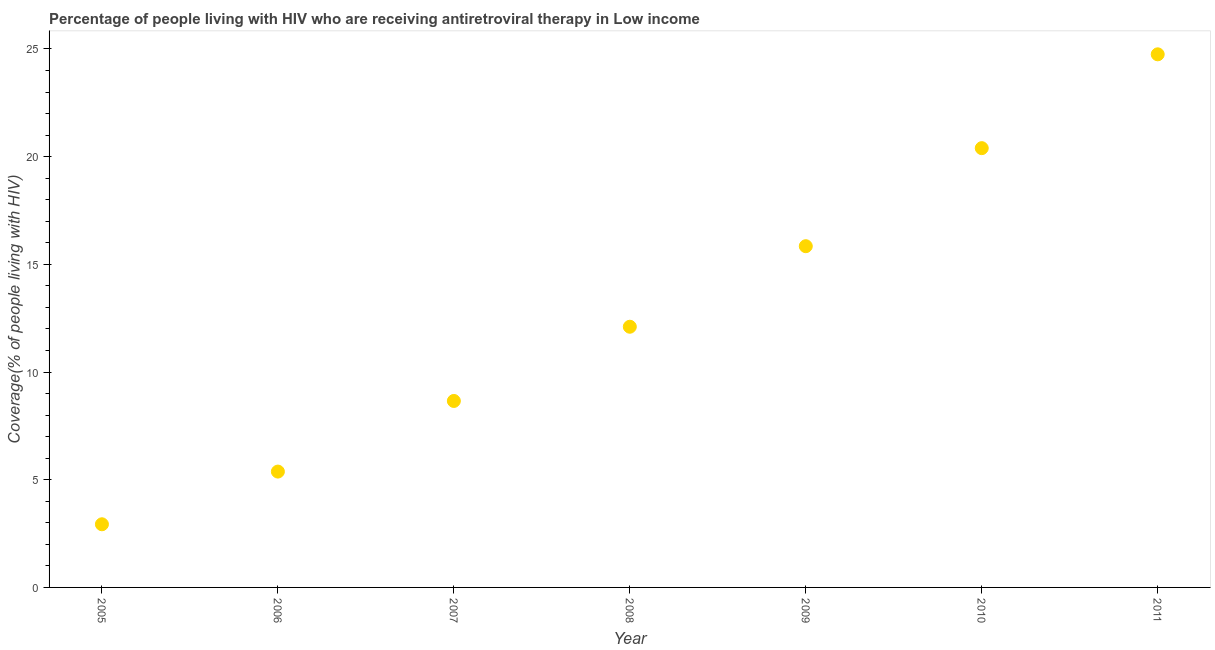What is the antiretroviral therapy coverage in 2008?
Keep it short and to the point. 12.1. Across all years, what is the maximum antiretroviral therapy coverage?
Ensure brevity in your answer.  24.75. Across all years, what is the minimum antiretroviral therapy coverage?
Your answer should be compact. 2.93. What is the sum of the antiretroviral therapy coverage?
Your answer should be very brief. 90.06. What is the difference between the antiretroviral therapy coverage in 2005 and 2009?
Provide a succinct answer. -12.91. What is the average antiretroviral therapy coverage per year?
Your answer should be very brief. 12.87. What is the median antiretroviral therapy coverage?
Ensure brevity in your answer.  12.1. In how many years, is the antiretroviral therapy coverage greater than 11 %?
Offer a terse response. 4. What is the ratio of the antiretroviral therapy coverage in 2005 to that in 2009?
Provide a succinct answer. 0.19. Is the antiretroviral therapy coverage in 2009 less than that in 2011?
Provide a succinct answer. Yes. Is the difference between the antiretroviral therapy coverage in 2010 and 2011 greater than the difference between any two years?
Ensure brevity in your answer.  No. What is the difference between the highest and the second highest antiretroviral therapy coverage?
Keep it short and to the point. 4.36. What is the difference between the highest and the lowest antiretroviral therapy coverage?
Provide a succinct answer. 21.82. Does the antiretroviral therapy coverage monotonically increase over the years?
Provide a short and direct response. Yes. How many dotlines are there?
Give a very brief answer. 1. Are the values on the major ticks of Y-axis written in scientific E-notation?
Ensure brevity in your answer.  No. Does the graph contain grids?
Your response must be concise. No. What is the title of the graph?
Offer a very short reply. Percentage of people living with HIV who are receiving antiretroviral therapy in Low income. What is the label or title of the Y-axis?
Give a very brief answer. Coverage(% of people living with HIV). What is the Coverage(% of people living with HIV) in 2005?
Give a very brief answer. 2.93. What is the Coverage(% of people living with HIV) in 2006?
Your response must be concise. 5.38. What is the Coverage(% of people living with HIV) in 2007?
Your response must be concise. 8.66. What is the Coverage(% of people living with HIV) in 2008?
Provide a succinct answer. 12.1. What is the Coverage(% of people living with HIV) in 2009?
Your answer should be compact. 15.84. What is the Coverage(% of people living with HIV) in 2010?
Ensure brevity in your answer.  20.39. What is the Coverage(% of people living with HIV) in 2011?
Provide a short and direct response. 24.75. What is the difference between the Coverage(% of people living with HIV) in 2005 and 2006?
Offer a very short reply. -2.45. What is the difference between the Coverage(% of people living with HIV) in 2005 and 2007?
Ensure brevity in your answer.  -5.73. What is the difference between the Coverage(% of people living with HIV) in 2005 and 2008?
Ensure brevity in your answer.  -9.17. What is the difference between the Coverage(% of people living with HIV) in 2005 and 2009?
Your response must be concise. -12.91. What is the difference between the Coverage(% of people living with HIV) in 2005 and 2010?
Give a very brief answer. -17.46. What is the difference between the Coverage(% of people living with HIV) in 2005 and 2011?
Provide a succinct answer. -21.82. What is the difference between the Coverage(% of people living with HIV) in 2006 and 2007?
Ensure brevity in your answer.  -3.28. What is the difference between the Coverage(% of people living with HIV) in 2006 and 2008?
Offer a very short reply. -6.72. What is the difference between the Coverage(% of people living with HIV) in 2006 and 2009?
Make the answer very short. -10.46. What is the difference between the Coverage(% of people living with HIV) in 2006 and 2010?
Offer a very short reply. -15.02. What is the difference between the Coverage(% of people living with HIV) in 2006 and 2011?
Offer a terse response. -19.37. What is the difference between the Coverage(% of people living with HIV) in 2007 and 2008?
Offer a very short reply. -3.45. What is the difference between the Coverage(% of people living with HIV) in 2007 and 2009?
Give a very brief answer. -7.18. What is the difference between the Coverage(% of people living with HIV) in 2007 and 2010?
Your answer should be compact. -11.74. What is the difference between the Coverage(% of people living with HIV) in 2007 and 2011?
Your answer should be very brief. -16.09. What is the difference between the Coverage(% of people living with HIV) in 2008 and 2009?
Provide a short and direct response. -3.74. What is the difference between the Coverage(% of people living with HIV) in 2008 and 2010?
Offer a very short reply. -8.29. What is the difference between the Coverage(% of people living with HIV) in 2008 and 2011?
Offer a terse response. -12.65. What is the difference between the Coverage(% of people living with HIV) in 2009 and 2010?
Give a very brief answer. -4.55. What is the difference between the Coverage(% of people living with HIV) in 2009 and 2011?
Your response must be concise. -8.91. What is the difference between the Coverage(% of people living with HIV) in 2010 and 2011?
Provide a short and direct response. -4.36. What is the ratio of the Coverage(% of people living with HIV) in 2005 to that in 2006?
Provide a succinct answer. 0.55. What is the ratio of the Coverage(% of people living with HIV) in 2005 to that in 2007?
Provide a short and direct response. 0.34. What is the ratio of the Coverage(% of people living with HIV) in 2005 to that in 2008?
Your response must be concise. 0.24. What is the ratio of the Coverage(% of people living with HIV) in 2005 to that in 2009?
Provide a short and direct response. 0.18. What is the ratio of the Coverage(% of people living with HIV) in 2005 to that in 2010?
Provide a short and direct response. 0.14. What is the ratio of the Coverage(% of people living with HIV) in 2005 to that in 2011?
Your response must be concise. 0.12. What is the ratio of the Coverage(% of people living with HIV) in 2006 to that in 2007?
Keep it short and to the point. 0.62. What is the ratio of the Coverage(% of people living with HIV) in 2006 to that in 2008?
Provide a succinct answer. 0.44. What is the ratio of the Coverage(% of people living with HIV) in 2006 to that in 2009?
Offer a very short reply. 0.34. What is the ratio of the Coverage(% of people living with HIV) in 2006 to that in 2010?
Your answer should be compact. 0.26. What is the ratio of the Coverage(% of people living with HIV) in 2006 to that in 2011?
Offer a very short reply. 0.22. What is the ratio of the Coverage(% of people living with HIV) in 2007 to that in 2008?
Provide a short and direct response. 0.71. What is the ratio of the Coverage(% of people living with HIV) in 2007 to that in 2009?
Your response must be concise. 0.55. What is the ratio of the Coverage(% of people living with HIV) in 2007 to that in 2010?
Keep it short and to the point. 0.42. What is the ratio of the Coverage(% of people living with HIV) in 2007 to that in 2011?
Make the answer very short. 0.35. What is the ratio of the Coverage(% of people living with HIV) in 2008 to that in 2009?
Your answer should be compact. 0.76. What is the ratio of the Coverage(% of people living with HIV) in 2008 to that in 2010?
Ensure brevity in your answer.  0.59. What is the ratio of the Coverage(% of people living with HIV) in 2008 to that in 2011?
Make the answer very short. 0.49. What is the ratio of the Coverage(% of people living with HIV) in 2009 to that in 2010?
Offer a terse response. 0.78. What is the ratio of the Coverage(% of people living with HIV) in 2009 to that in 2011?
Make the answer very short. 0.64. What is the ratio of the Coverage(% of people living with HIV) in 2010 to that in 2011?
Your response must be concise. 0.82. 